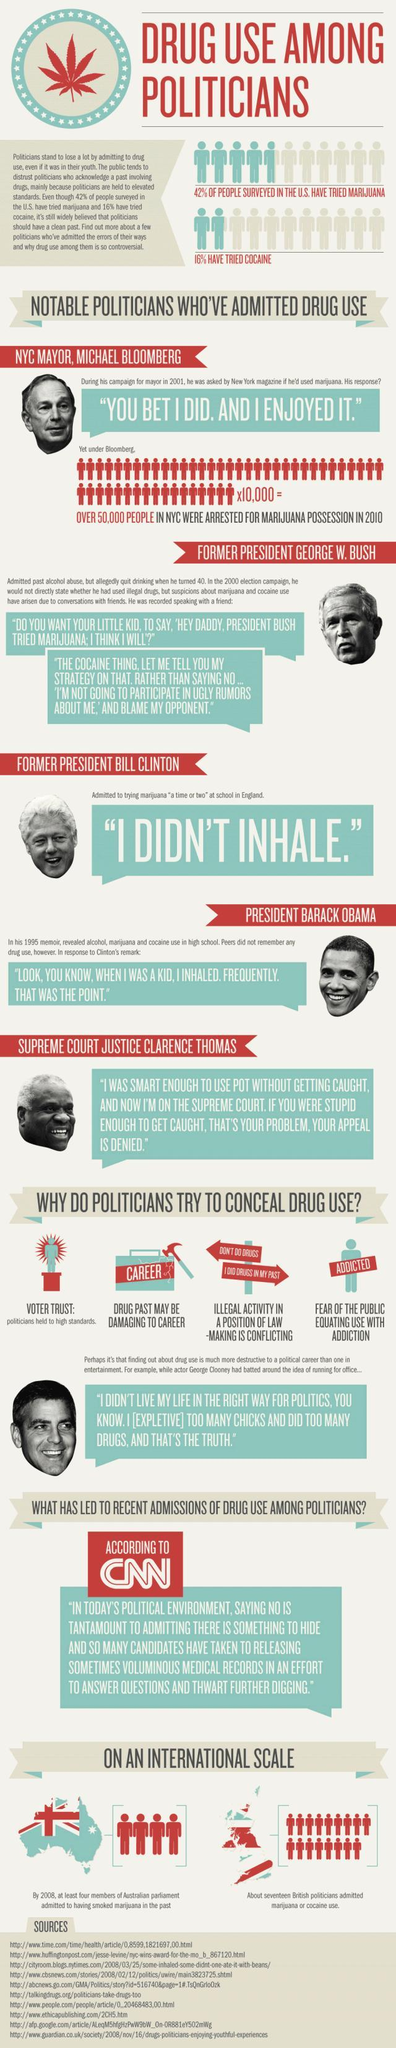Among the pictures of famous personalities given, how many of them were Presidents of USA?
Answer the question with a short phrase. 3 What is the second reason for politicians trying to hide drug use? Drug past maybe damaging to career 